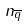Convert formula to latex. <formula><loc_0><loc_0><loc_500><loc_500>n _ { \overline { q } }</formula> 